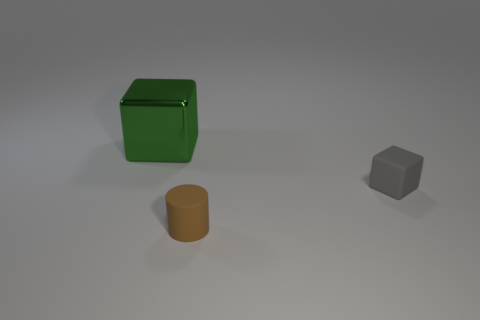Is there any other thing that is the same size as the metallic cube?
Ensure brevity in your answer.  No. Are there any brown cylinders that have the same material as the gray thing?
Give a very brief answer. Yes. There is a small rubber thing that is behind the small cylinder; is there a large metallic cube that is in front of it?
Provide a succinct answer. No. There is a block right of the tiny brown rubber object; what is its material?
Provide a succinct answer. Rubber. Do the small gray rubber thing and the large shiny thing have the same shape?
Your answer should be very brief. Yes. The rubber thing that is on the right side of the matte thing in front of the block that is in front of the large green thing is what color?
Offer a terse response. Gray. How many tiny rubber objects are the same shape as the large metallic object?
Offer a very short reply. 1. There is a block behind the cube that is in front of the big green metallic object; what size is it?
Offer a terse response. Large. Does the brown cylinder have the same size as the shiny cube?
Your answer should be very brief. No. There is a block that is left of the block in front of the large green thing; are there any brown cylinders that are to the right of it?
Give a very brief answer. Yes. 